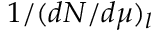Convert formula to latex. <formula><loc_0><loc_0><loc_500><loc_500>1 / ( d N / d \mu ) _ { l }</formula> 